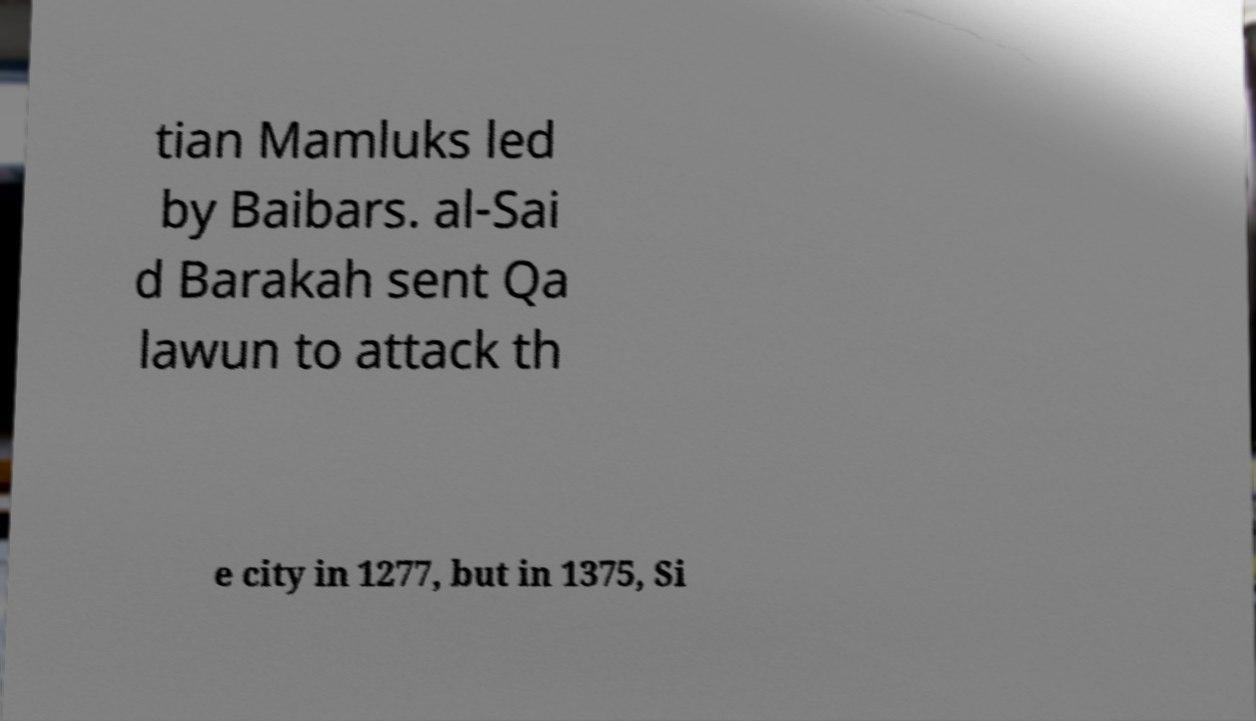Can you read and provide the text displayed in the image?This photo seems to have some interesting text. Can you extract and type it out for me? tian Mamluks led by Baibars. al-Sai d Barakah sent Qa lawun to attack th e city in 1277, but in 1375, Si 